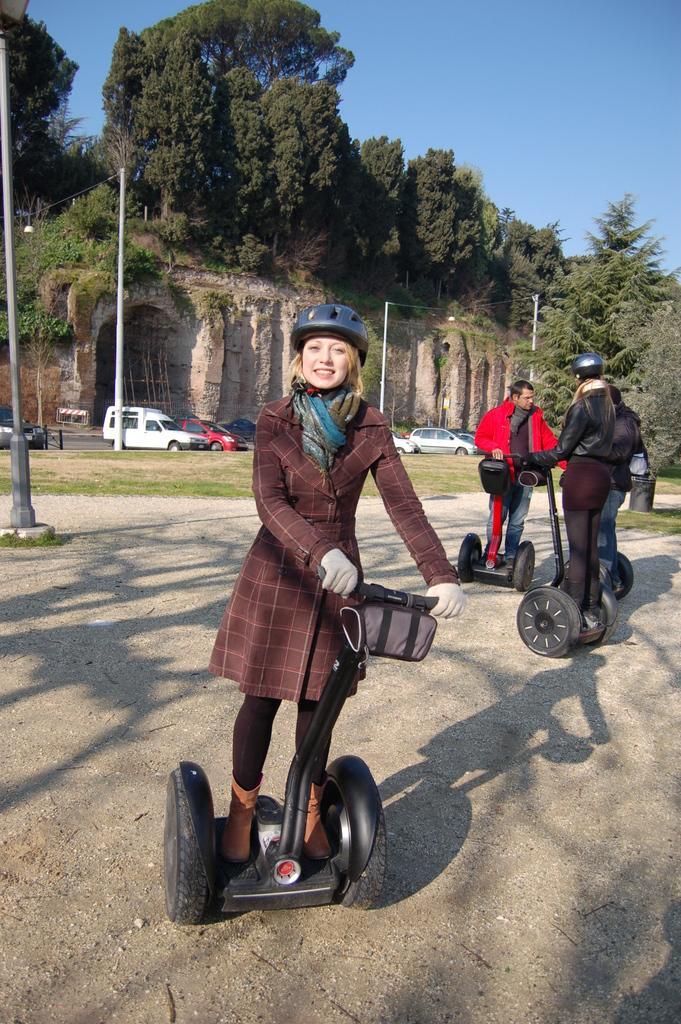Could you give a brief overview of what you see in this image? There are four persons in different color dresses, standing on the Segways and driving them, on the ground. In the background, there are vehicles parked on the road, there is a grass on the ground, there are poles, there are trees on the hill and there is blue sky. 